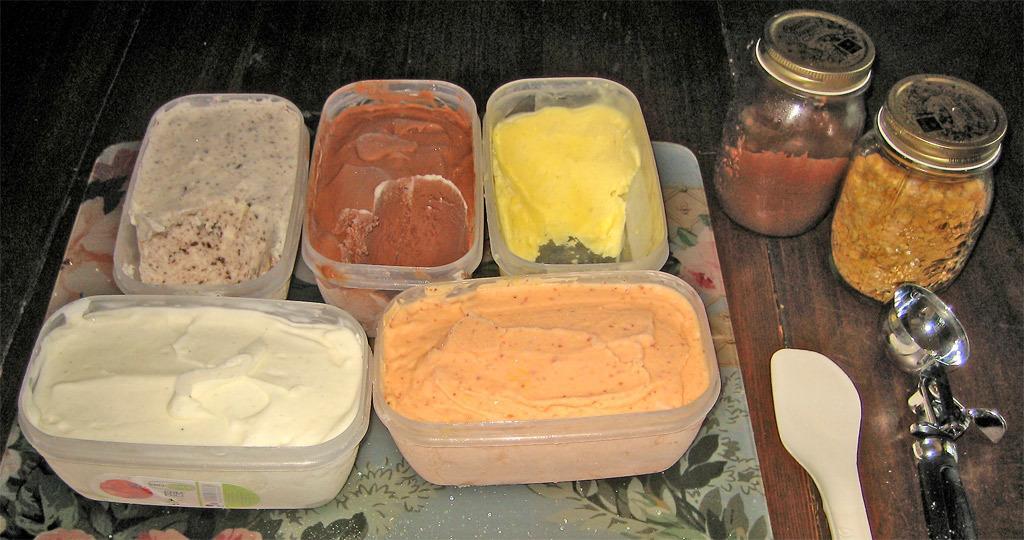In one or two sentences, can you explain what this image depicts? In this image there is a tray with some ice cream boxes in it, beside that there are two jars with some toppings and also there is a scooper and some white spoon. 